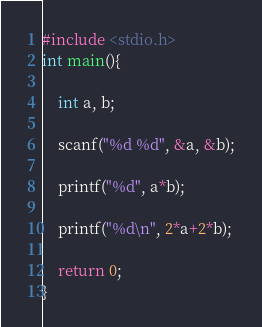Convert code to text. <code><loc_0><loc_0><loc_500><loc_500><_C_>#include <stdio.h>
int main(){

    int a, b;

    scanf("%d %d", &a, &b);

    printf("%d", a*b);

    printf("%d\n", 2*a+2*b);

    return 0;
}
</code> 